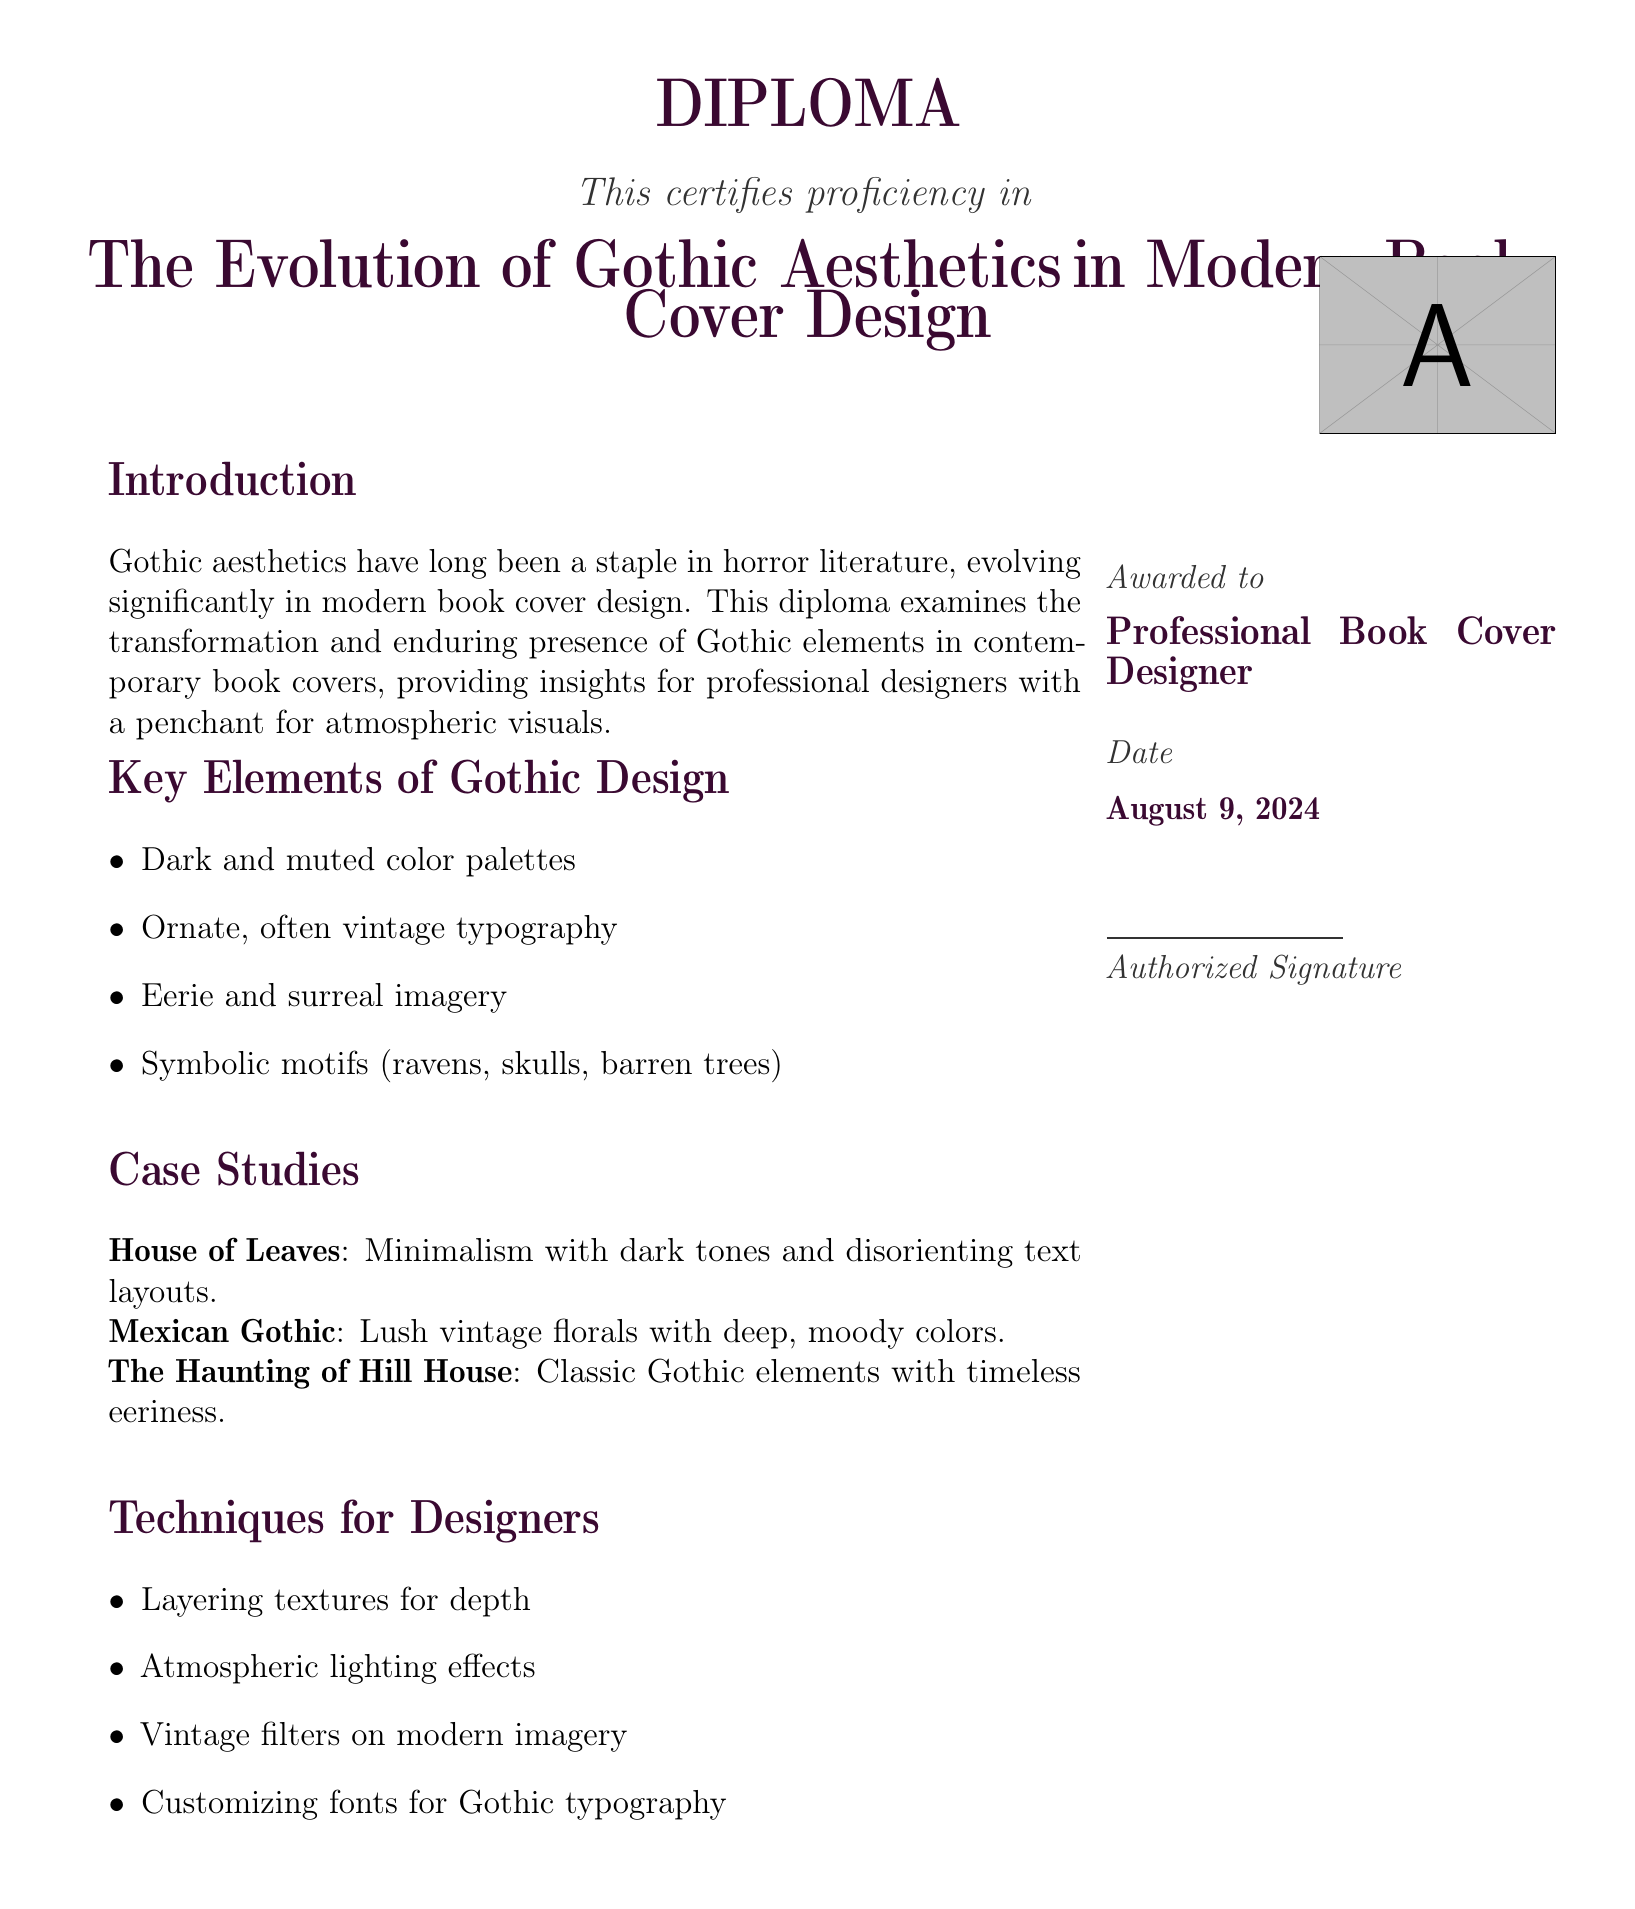What is the title of the diploma? The title of the diploma is presented prominently in the document, stating the focus of the certification.
Answer: The Evolution of Gothic Aesthetics in Modern Book Cover Design What color is used for the section titles? The section titles are designed in a specific color that reflects the Gothic aesthetic, enhancing the document's theme.
Answer: Gothic purple What element is included in the introduction? The introduction outlines the focus and purpose of the diploma as it relates to Gothic aesthetics in design.
Answer: Examination of Gothic aesthetics What type of motifs are mentioned in the key elements? The key elements detail specific symbolic motifs that are associated with Gothic design, which are visually impactful.
Answer: Ravens, skulls, barren trees Which book cover represents minimalism? The document provides specific case studies that illustrate different approaches to Gothic aesthetics, including one that emphasizes minimalism.
Answer: House of Leaves What date is on the diploma? The date at the bottom of the document indicates the time of issuance for the diploma, relevant for professional credentials.
Answer: Today's date What effect is suggested for designers? The techniques for designers section recommends specific methods to create Gothic aesthetics, focusing on visual depth.
Answer: Atmospheric lighting effects Who is the diploma awarded to? The document specifies the recipient of the diploma, indicating the professional scope of the certification.
Answer: Professional Book Cover Designer What is the purpose of the case studies? The case studies serve to illustrate real-world applications of Gothic aesthetics in a modern context, aiding designers' understanding.
Answer: Provide insights for designers 